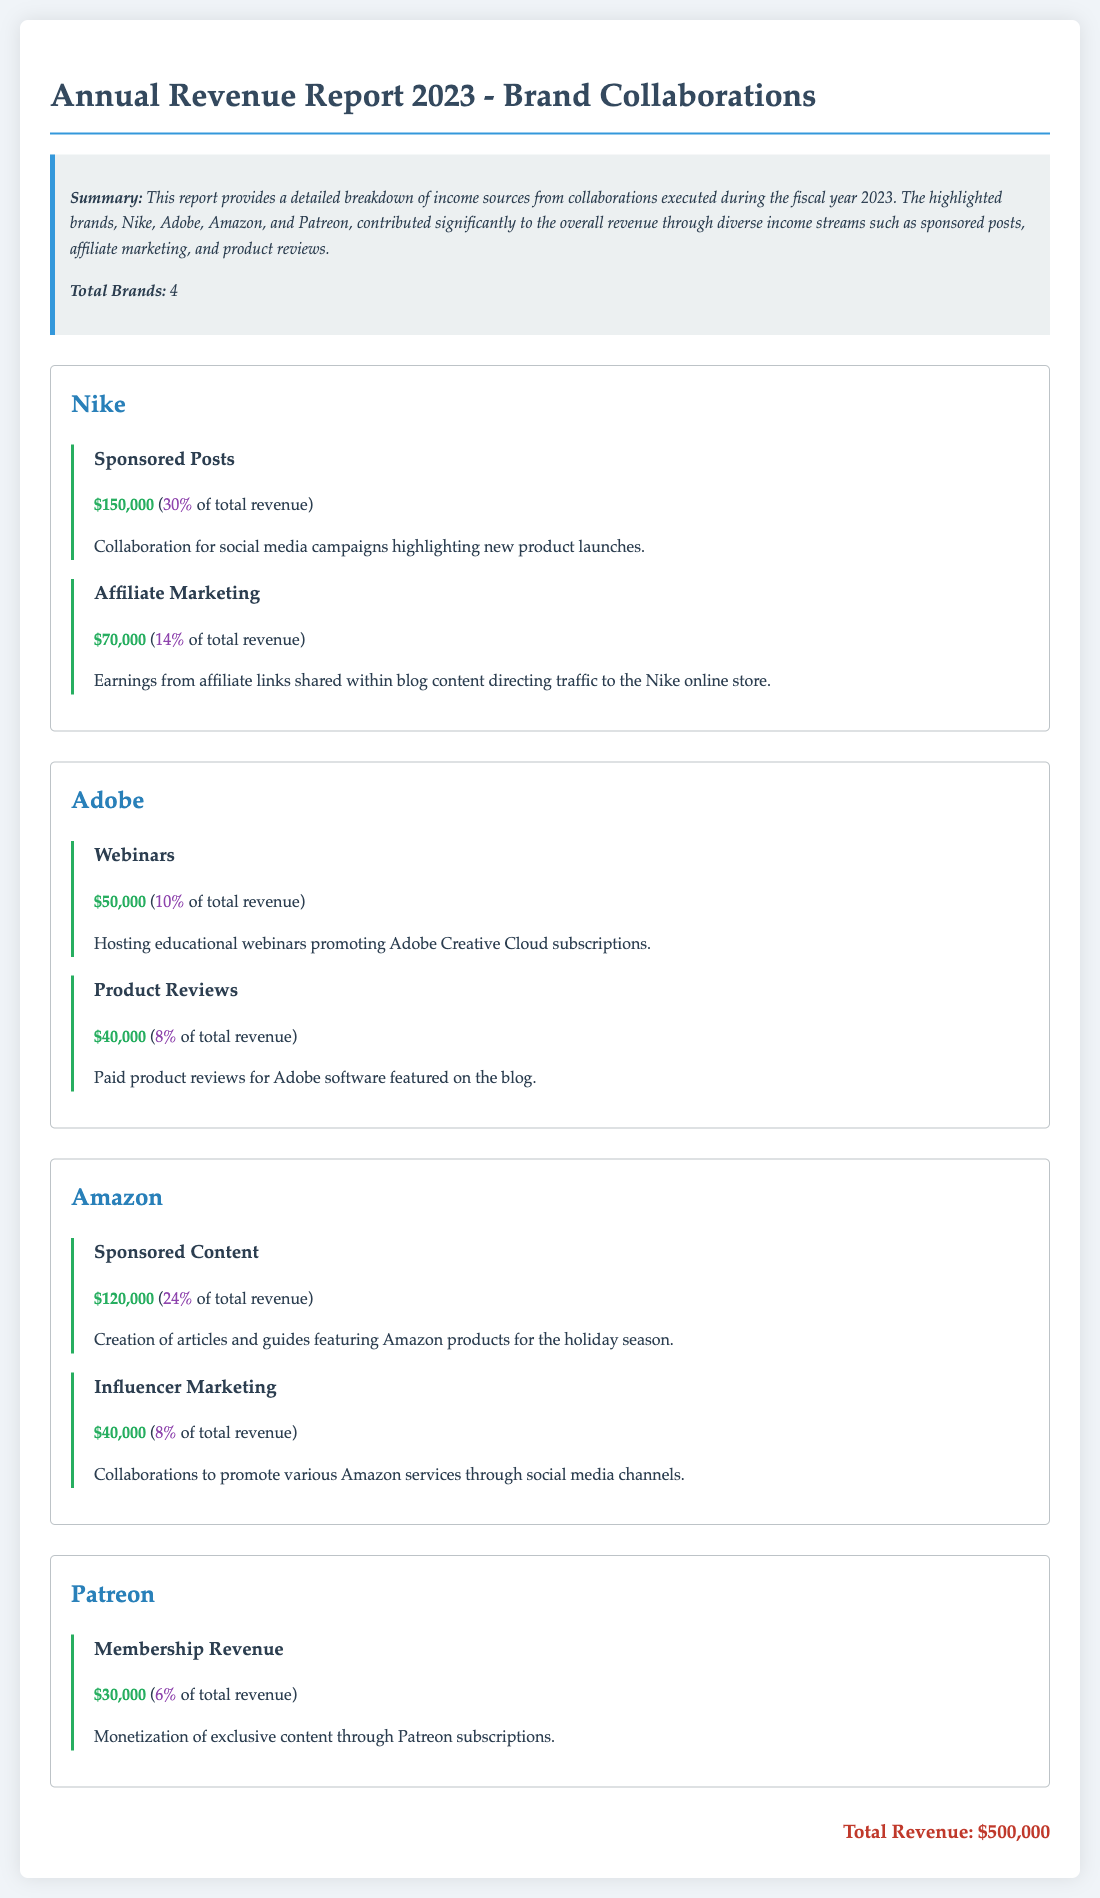What was the total revenue for 2023? The total revenue is listed at the end of the document and sums all income from brand collaborations.
Answer: $500,000 How much did Nike earn from Sponsored Posts? The amount for Sponsored Posts under the Nike section is specified in the income source details.
Answer: $150,000 What percentage of total revenue is derived from Affiliate Marketing with Nike? The percentage is provided alongside the income amount in the document.
Answer: 14% Which brand generated revenue through Webinars? The brand associated with Webinars is mentioned in the corresponding section with income details.
Answer: Adobe How much did Amazon contribute through Sponsored Content? The amount for Sponsored Content from the Amazon section is stated clearly in the report.
Answer: $120,000 What is the income from Membership Revenue with Patreon? The document specifies the income from Membership Revenue in the Patreon section.
Answer: $30,000 How many brands are featured in this revenue report? The total number of brands is summarized at the beginning of the document.
Answer: 4 Which income source generated the least revenue? The document outlines all income sources, allowing us to identify the least earning source.
Answer: Membership Revenue 